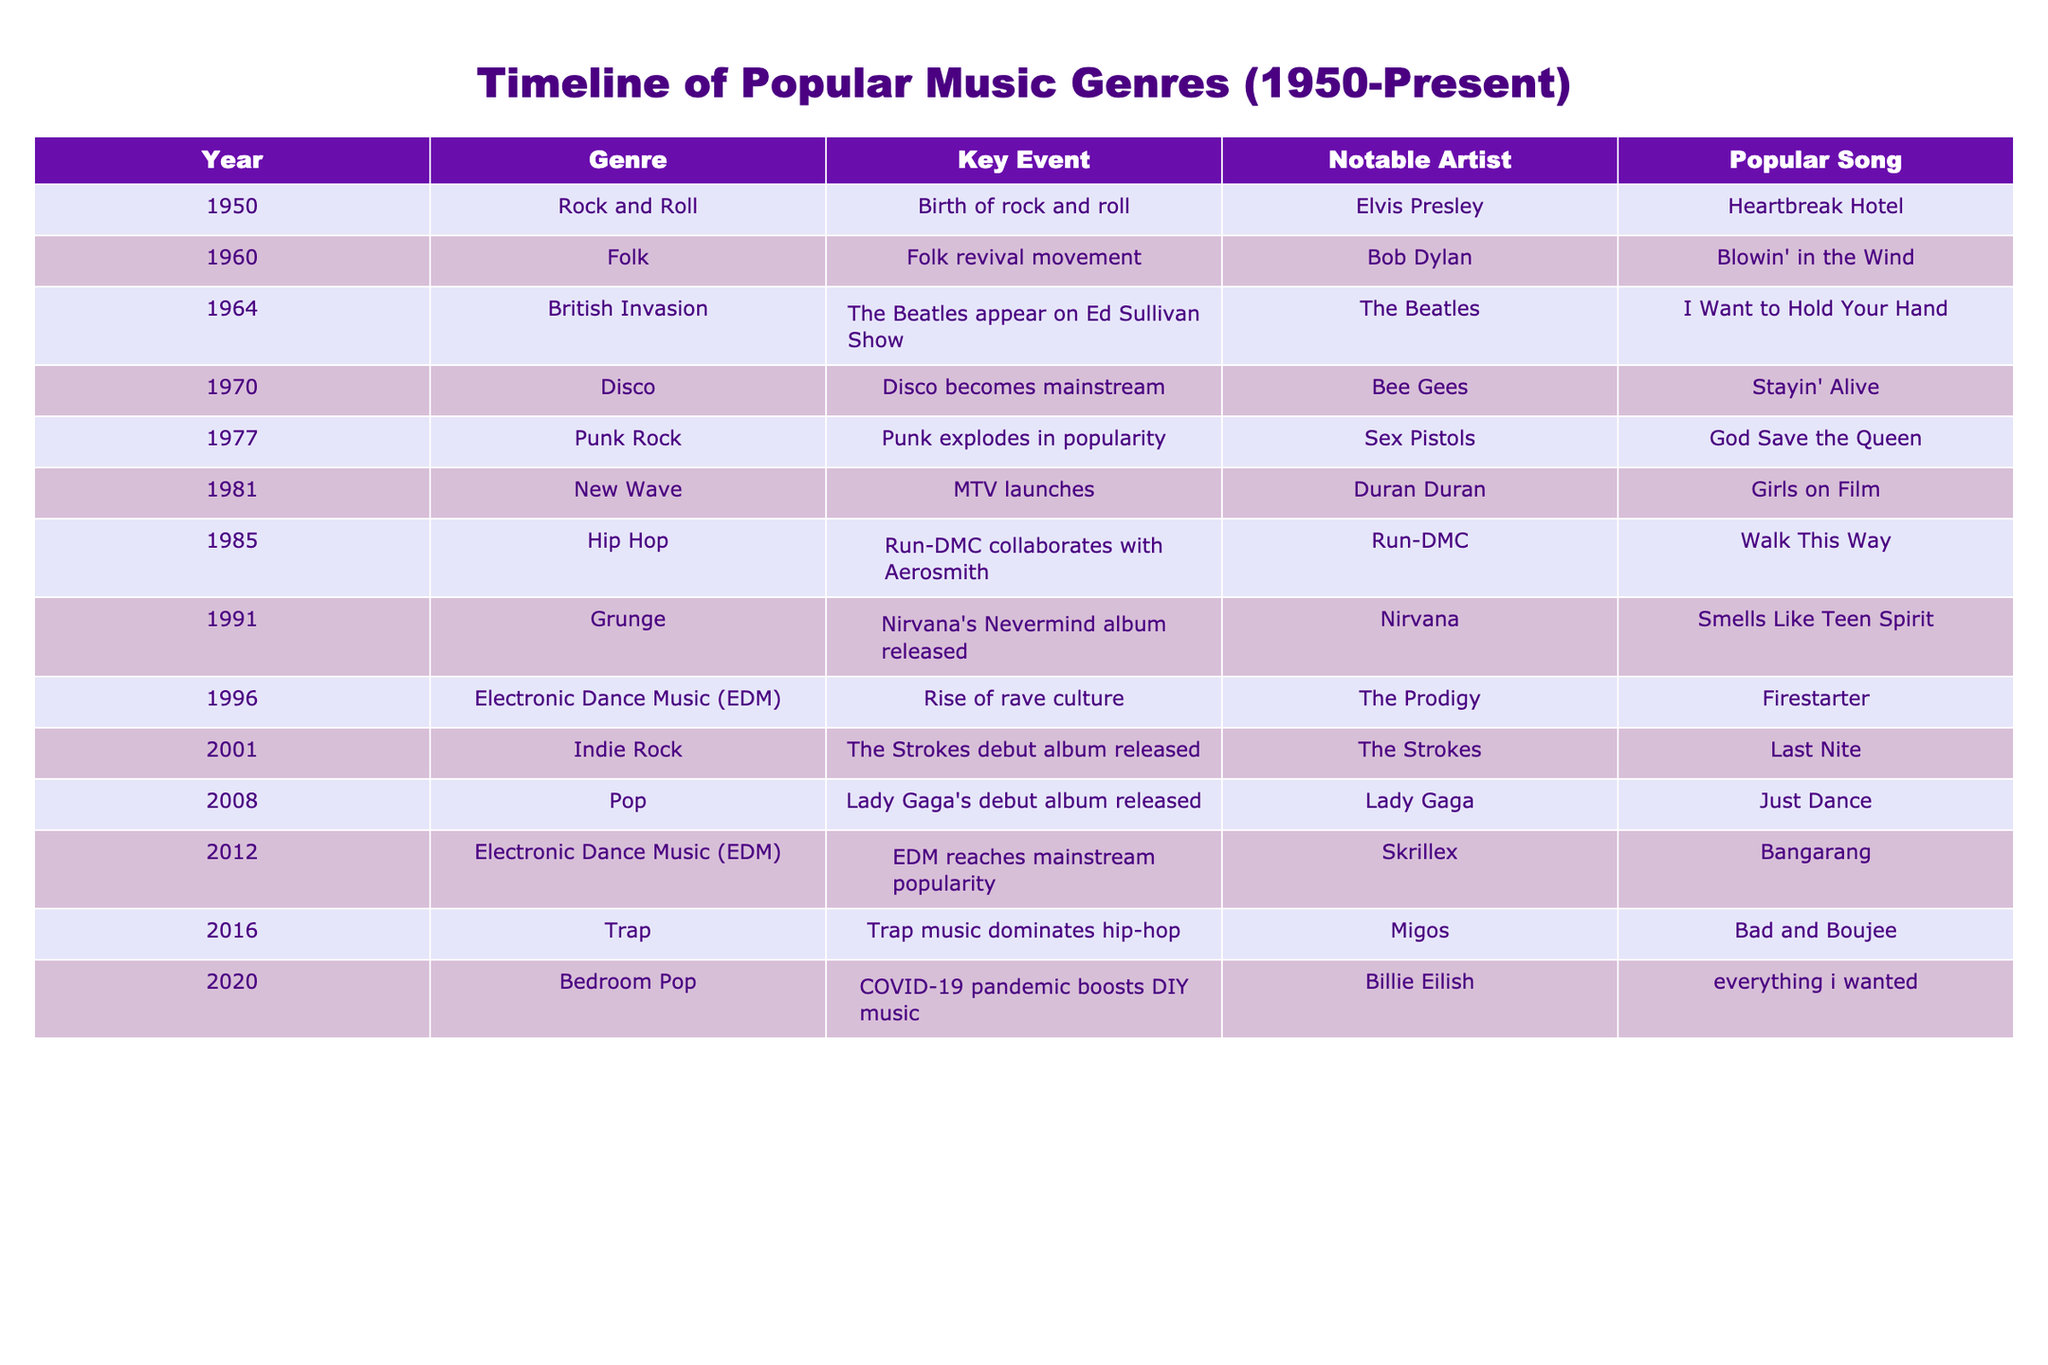What genre was popular in 1970? According to the table, in the year 1970, the genre that became mainstream was Disco.
Answer: Disco Which artist is associated with the popular song "Blowin' in the Wind"? The table indicates that Bob Dylan is the artist associated with the song "Blowin' in the Wind."
Answer: Bob Dylan What major event occurred in 2001 related to Indie Rock? The table notes that in 2001, The Strokes released their debut album, which signifies a major event for the Indie Rock genre.
Answer: The Strokes debut album released Is the year 2016 associated with the genre Trap? Yes, according to the table, the genre Trap is associated with the year 2016.
Answer: Yes What was the popular song in the genre Electronic Dance Music in 2012? The table specifies that the popular song in the Electronic Dance Music genre in 2012 was "Bangarang" by Skrillex.
Answer: Bangarang How many genres became popular in the 1980s based on the table? Analyzing the table shows that there are three entries that represent the 1980s: New Wave (1981), Hip Hop (1985), and Disco (1980 can be inferred as mentioned). Therefore, three genres became popular in that decade.
Answer: Three What is the notable artist for the popular song "Stayin' Alive"? Looking at the table for the 1970 entry, the notable artist for the song "Stayin' Alive" is the Bee Gees.
Answer: Bee Gees Which genre had a revival movement in the 1960s? The table highlights that the 1960s saw the Folk genre experience a revival movement.
Answer: Folk What year did Lady Gaga release her debut album? According to the table, Lady Gaga released her debut album in 2008.
Answer: 2008 